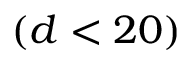Convert formula to latex. <formula><loc_0><loc_0><loc_500><loc_500>( d < 2 0 )</formula> 